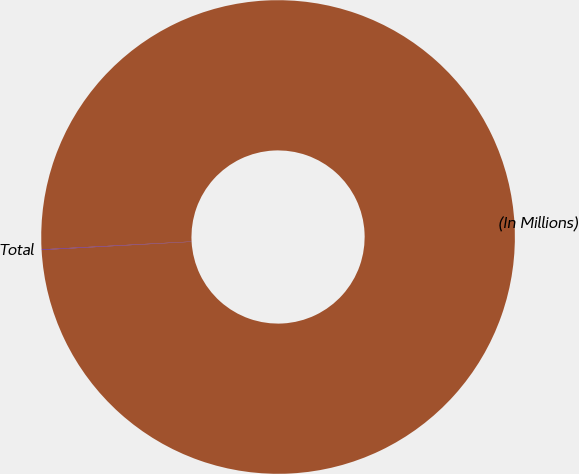Convert chart to OTSL. <chart><loc_0><loc_0><loc_500><loc_500><pie_chart><fcel>(In Millions)<fcel>Total<nl><fcel>99.96%<fcel>0.04%<nl></chart> 